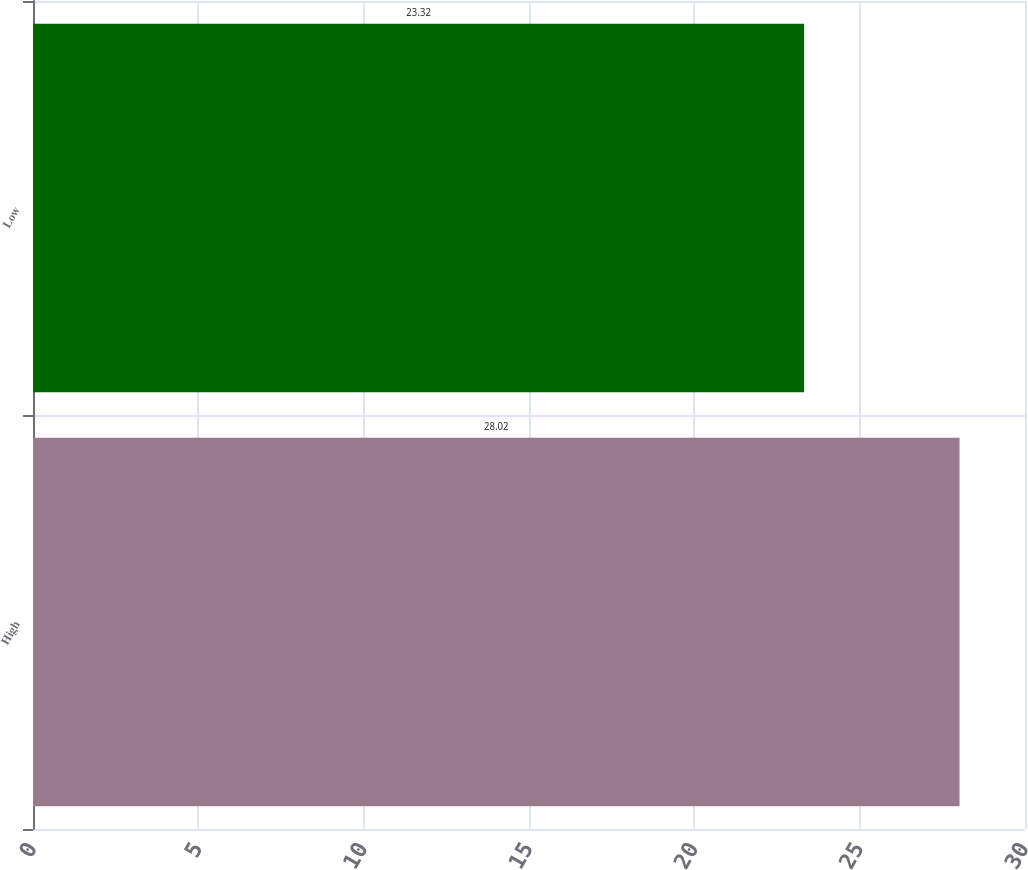Convert chart to OTSL. <chart><loc_0><loc_0><loc_500><loc_500><bar_chart><fcel>High<fcel>Low<nl><fcel>28.02<fcel>23.32<nl></chart> 